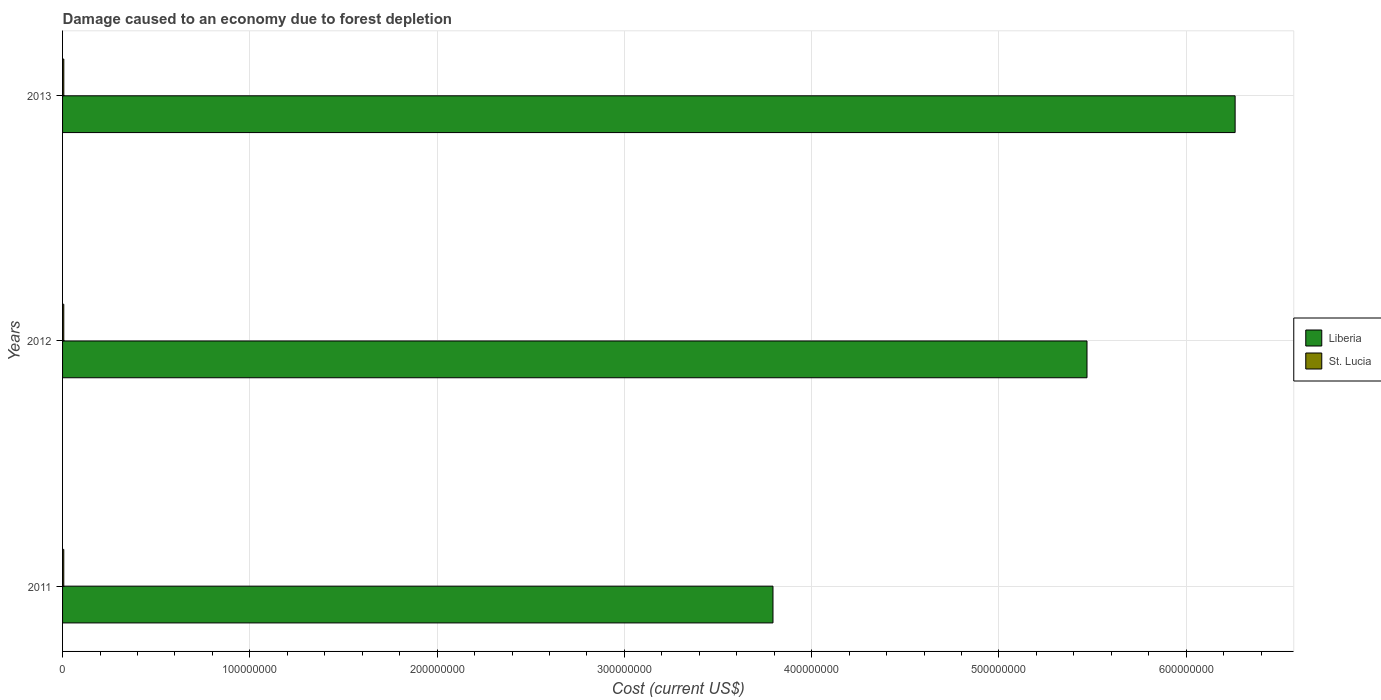How many groups of bars are there?
Provide a short and direct response. 3. Are the number of bars per tick equal to the number of legend labels?
Your response must be concise. Yes. Are the number of bars on each tick of the Y-axis equal?
Provide a succinct answer. Yes. How many bars are there on the 1st tick from the top?
Offer a terse response. 2. How many bars are there on the 2nd tick from the bottom?
Make the answer very short. 2. What is the label of the 3rd group of bars from the top?
Your response must be concise. 2011. What is the cost of damage caused due to forest depletion in Liberia in 2011?
Your answer should be compact. 3.79e+08. Across all years, what is the maximum cost of damage caused due to forest depletion in St. Lucia?
Make the answer very short. 6.69e+05. Across all years, what is the minimum cost of damage caused due to forest depletion in St. Lucia?
Provide a succinct answer. 6.47e+05. In which year was the cost of damage caused due to forest depletion in St. Lucia maximum?
Offer a terse response. 2013. What is the total cost of damage caused due to forest depletion in Liberia in the graph?
Your answer should be very brief. 1.55e+09. What is the difference between the cost of damage caused due to forest depletion in Liberia in 2012 and that in 2013?
Provide a succinct answer. -7.91e+07. What is the difference between the cost of damage caused due to forest depletion in St. Lucia in 2013 and the cost of damage caused due to forest depletion in Liberia in 2012?
Give a very brief answer. -5.46e+08. What is the average cost of damage caused due to forest depletion in Liberia per year?
Your answer should be compact. 5.18e+08. In the year 2011, what is the difference between the cost of damage caused due to forest depletion in Liberia and cost of damage caused due to forest depletion in St. Lucia?
Offer a very short reply. 3.79e+08. In how many years, is the cost of damage caused due to forest depletion in St. Lucia greater than 440000000 US$?
Keep it short and to the point. 0. What is the ratio of the cost of damage caused due to forest depletion in St. Lucia in 2011 to that in 2012?
Keep it short and to the point. 1. Is the cost of damage caused due to forest depletion in St. Lucia in 2012 less than that in 2013?
Your response must be concise. Yes. Is the difference between the cost of damage caused due to forest depletion in Liberia in 2011 and 2012 greater than the difference between the cost of damage caused due to forest depletion in St. Lucia in 2011 and 2012?
Ensure brevity in your answer.  No. What is the difference between the highest and the second highest cost of damage caused due to forest depletion in St. Lucia?
Keep it short and to the point. 2.09e+04. What is the difference between the highest and the lowest cost of damage caused due to forest depletion in St. Lucia?
Offer a very short reply. 2.20e+04. In how many years, is the cost of damage caused due to forest depletion in St. Lucia greater than the average cost of damage caused due to forest depletion in St. Lucia taken over all years?
Make the answer very short. 1. What does the 1st bar from the top in 2012 represents?
Your response must be concise. St. Lucia. What does the 2nd bar from the bottom in 2011 represents?
Your answer should be compact. St. Lucia. How many bars are there?
Make the answer very short. 6. Are the values on the major ticks of X-axis written in scientific E-notation?
Offer a terse response. No. Does the graph contain any zero values?
Give a very brief answer. No. Does the graph contain grids?
Make the answer very short. Yes. Where does the legend appear in the graph?
Offer a very short reply. Center right. How many legend labels are there?
Your answer should be compact. 2. What is the title of the graph?
Your answer should be very brief. Damage caused to an economy due to forest depletion. Does "Bolivia" appear as one of the legend labels in the graph?
Your response must be concise. No. What is the label or title of the X-axis?
Provide a succinct answer. Cost (current US$). What is the Cost (current US$) in Liberia in 2011?
Provide a short and direct response. 3.79e+08. What is the Cost (current US$) in St. Lucia in 2011?
Ensure brevity in your answer.  6.47e+05. What is the Cost (current US$) in Liberia in 2012?
Offer a terse response. 5.47e+08. What is the Cost (current US$) of St. Lucia in 2012?
Your response must be concise. 6.48e+05. What is the Cost (current US$) of Liberia in 2013?
Provide a succinct answer. 6.26e+08. What is the Cost (current US$) of St. Lucia in 2013?
Your answer should be very brief. 6.69e+05. Across all years, what is the maximum Cost (current US$) of Liberia?
Your answer should be compact. 6.26e+08. Across all years, what is the maximum Cost (current US$) in St. Lucia?
Your answer should be compact. 6.69e+05. Across all years, what is the minimum Cost (current US$) of Liberia?
Offer a very short reply. 3.79e+08. Across all years, what is the minimum Cost (current US$) of St. Lucia?
Provide a short and direct response. 6.47e+05. What is the total Cost (current US$) in Liberia in the graph?
Your answer should be very brief. 1.55e+09. What is the total Cost (current US$) in St. Lucia in the graph?
Keep it short and to the point. 1.96e+06. What is the difference between the Cost (current US$) of Liberia in 2011 and that in 2012?
Keep it short and to the point. -1.68e+08. What is the difference between the Cost (current US$) of St. Lucia in 2011 and that in 2012?
Give a very brief answer. -1033.85. What is the difference between the Cost (current US$) in Liberia in 2011 and that in 2013?
Your answer should be compact. -2.47e+08. What is the difference between the Cost (current US$) of St. Lucia in 2011 and that in 2013?
Your answer should be compact. -2.20e+04. What is the difference between the Cost (current US$) in Liberia in 2012 and that in 2013?
Your response must be concise. -7.91e+07. What is the difference between the Cost (current US$) in St. Lucia in 2012 and that in 2013?
Your answer should be compact. -2.09e+04. What is the difference between the Cost (current US$) of Liberia in 2011 and the Cost (current US$) of St. Lucia in 2012?
Offer a terse response. 3.79e+08. What is the difference between the Cost (current US$) of Liberia in 2011 and the Cost (current US$) of St. Lucia in 2013?
Offer a terse response. 3.79e+08. What is the difference between the Cost (current US$) in Liberia in 2012 and the Cost (current US$) in St. Lucia in 2013?
Ensure brevity in your answer.  5.46e+08. What is the average Cost (current US$) of Liberia per year?
Give a very brief answer. 5.18e+08. What is the average Cost (current US$) in St. Lucia per year?
Offer a very short reply. 6.55e+05. In the year 2011, what is the difference between the Cost (current US$) in Liberia and Cost (current US$) in St. Lucia?
Your answer should be very brief. 3.79e+08. In the year 2012, what is the difference between the Cost (current US$) of Liberia and Cost (current US$) of St. Lucia?
Offer a very short reply. 5.46e+08. In the year 2013, what is the difference between the Cost (current US$) in Liberia and Cost (current US$) in St. Lucia?
Your answer should be very brief. 6.25e+08. What is the ratio of the Cost (current US$) in Liberia in 2011 to that in 2012?
Offer a very short reply. 0.69. What is the ratio of the Cost (current US$) of Liberia in 2011 to that in 2013?
Keep it short and to the point. 0.61. What is the ratio of the Cost (current US$) in St. Lucia in 2011 to that in 2013?
Provide a short and direct response. 0.97. What is the ratio of the Cost (current US$) of Liberia in 2012 to that in 2013?
Offer a very short reply. 0.87. What is the ratio of the Cost (current US$) in St. Lucia in 2012 to that in 2013?
Your answer should be very brief. 0.97. What is the difference between the highest and the second highest Cost (current US$) in Liberia?
Offer a terse response. 7.91e+07. What is the difference between the highest and the second highest Cost (current US$) in St. Lucia?
Give a very brief answer. 2.09e+04. What is the difference between the highest and the lowest Cost (current US$) of Liberia?
Make the answer very short. 2.47e+08. What is the difference between the highest and the lowest Cost (current US$) of St. Lucia?
Provide a short and direct response. 2.20e+04. 